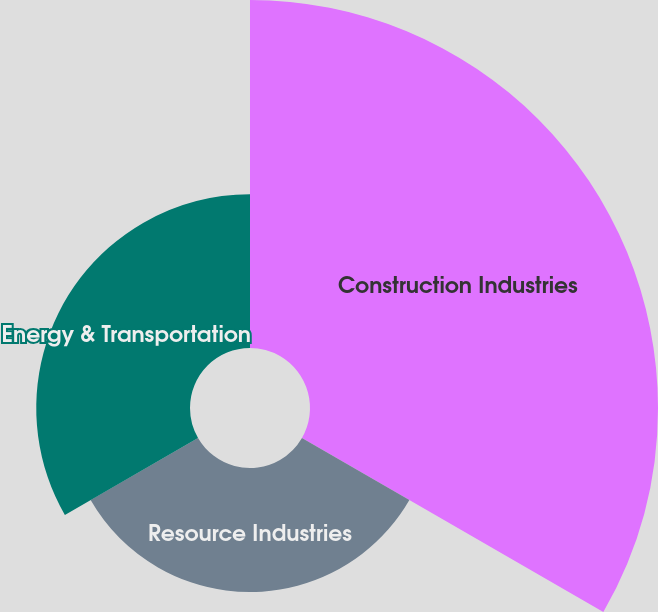Convert chart. <chart><loc_0><loc_0><loc_500><loc_500><pie_chart><fcel>Construction Industries<fcel>Resource Industries<fcel>Energy & Transportation<nl><fcel>55.61%<fcel>19.82%<fcel>24.57%<nl></chart> 